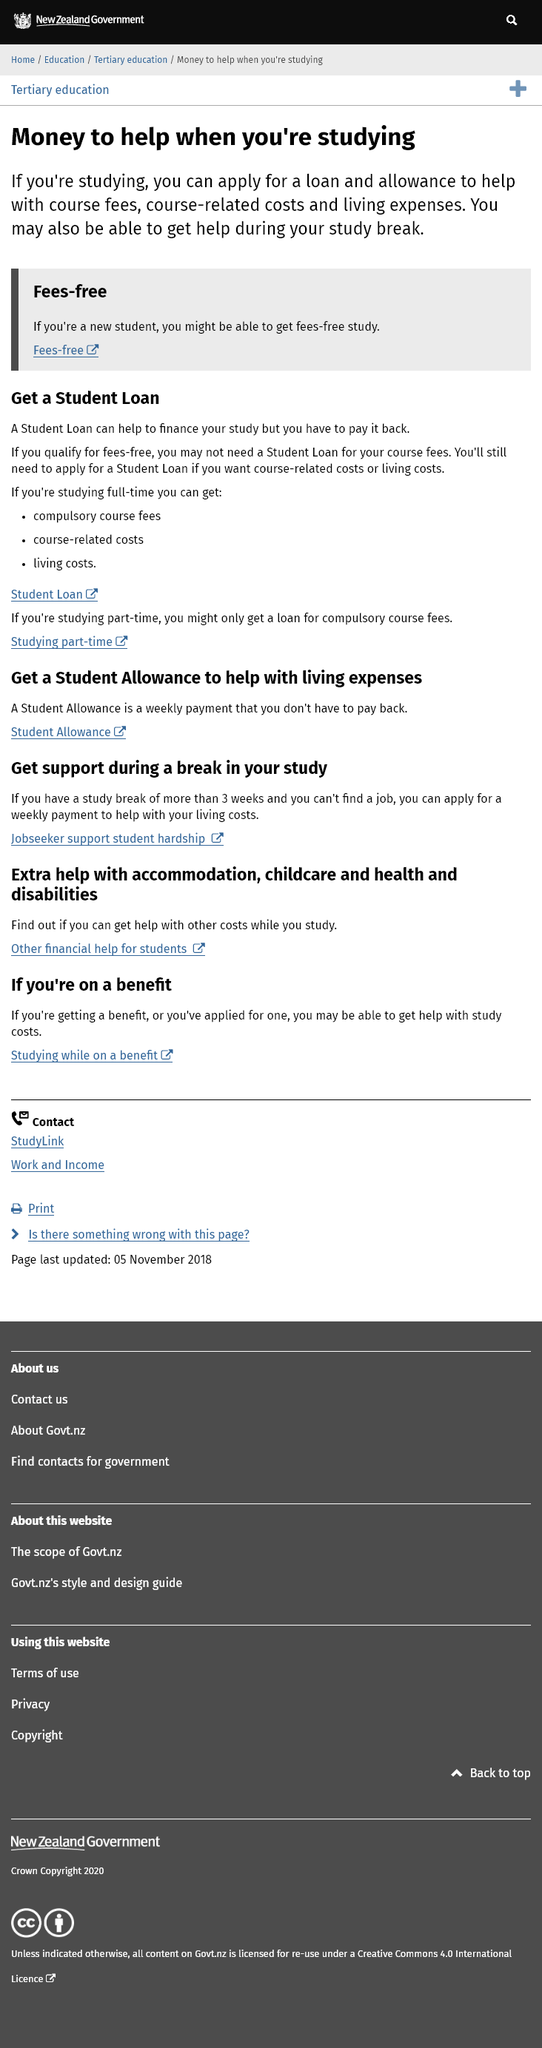Draw attention to some important aspects in this diagram. Studying part-time allows for the availability of a loan for compulsory course fees. If you are studying, you can apply for loans and allowances. Yes, students can receive financial assistance for childcare. Studying full-time can lead to significant financial savings, as it allows for the reduction of costs associated with compulsory course fees, course-related expenses, and living expenses. It is not necessary to repay a student allowance. 